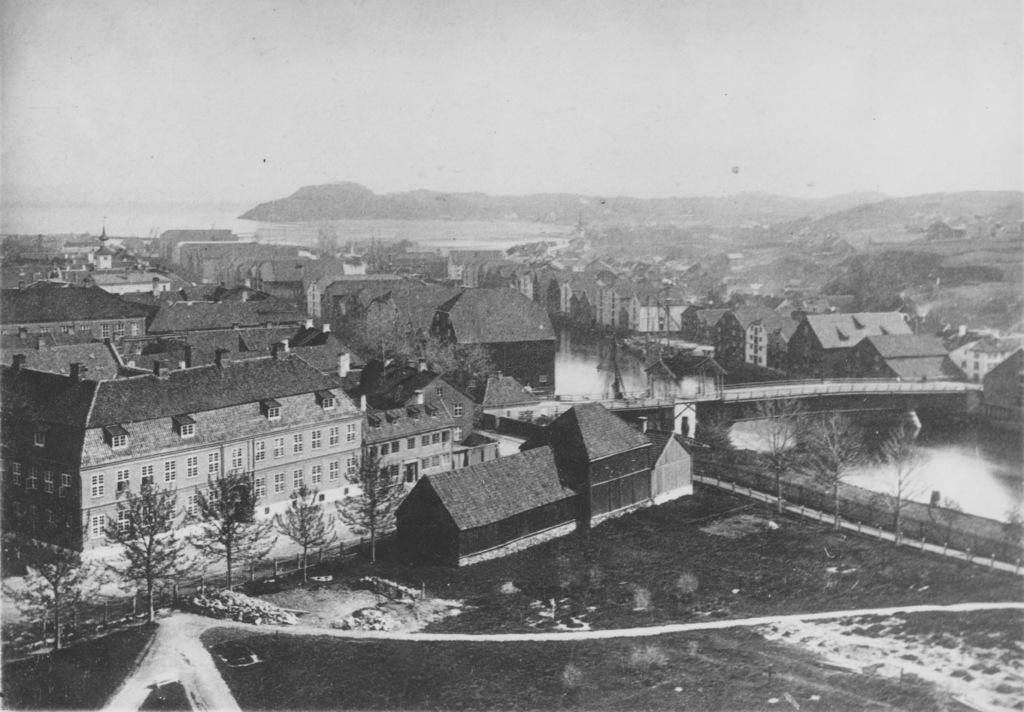Can you describe this image briefly? These are houses and trees, this is water and a sky. 